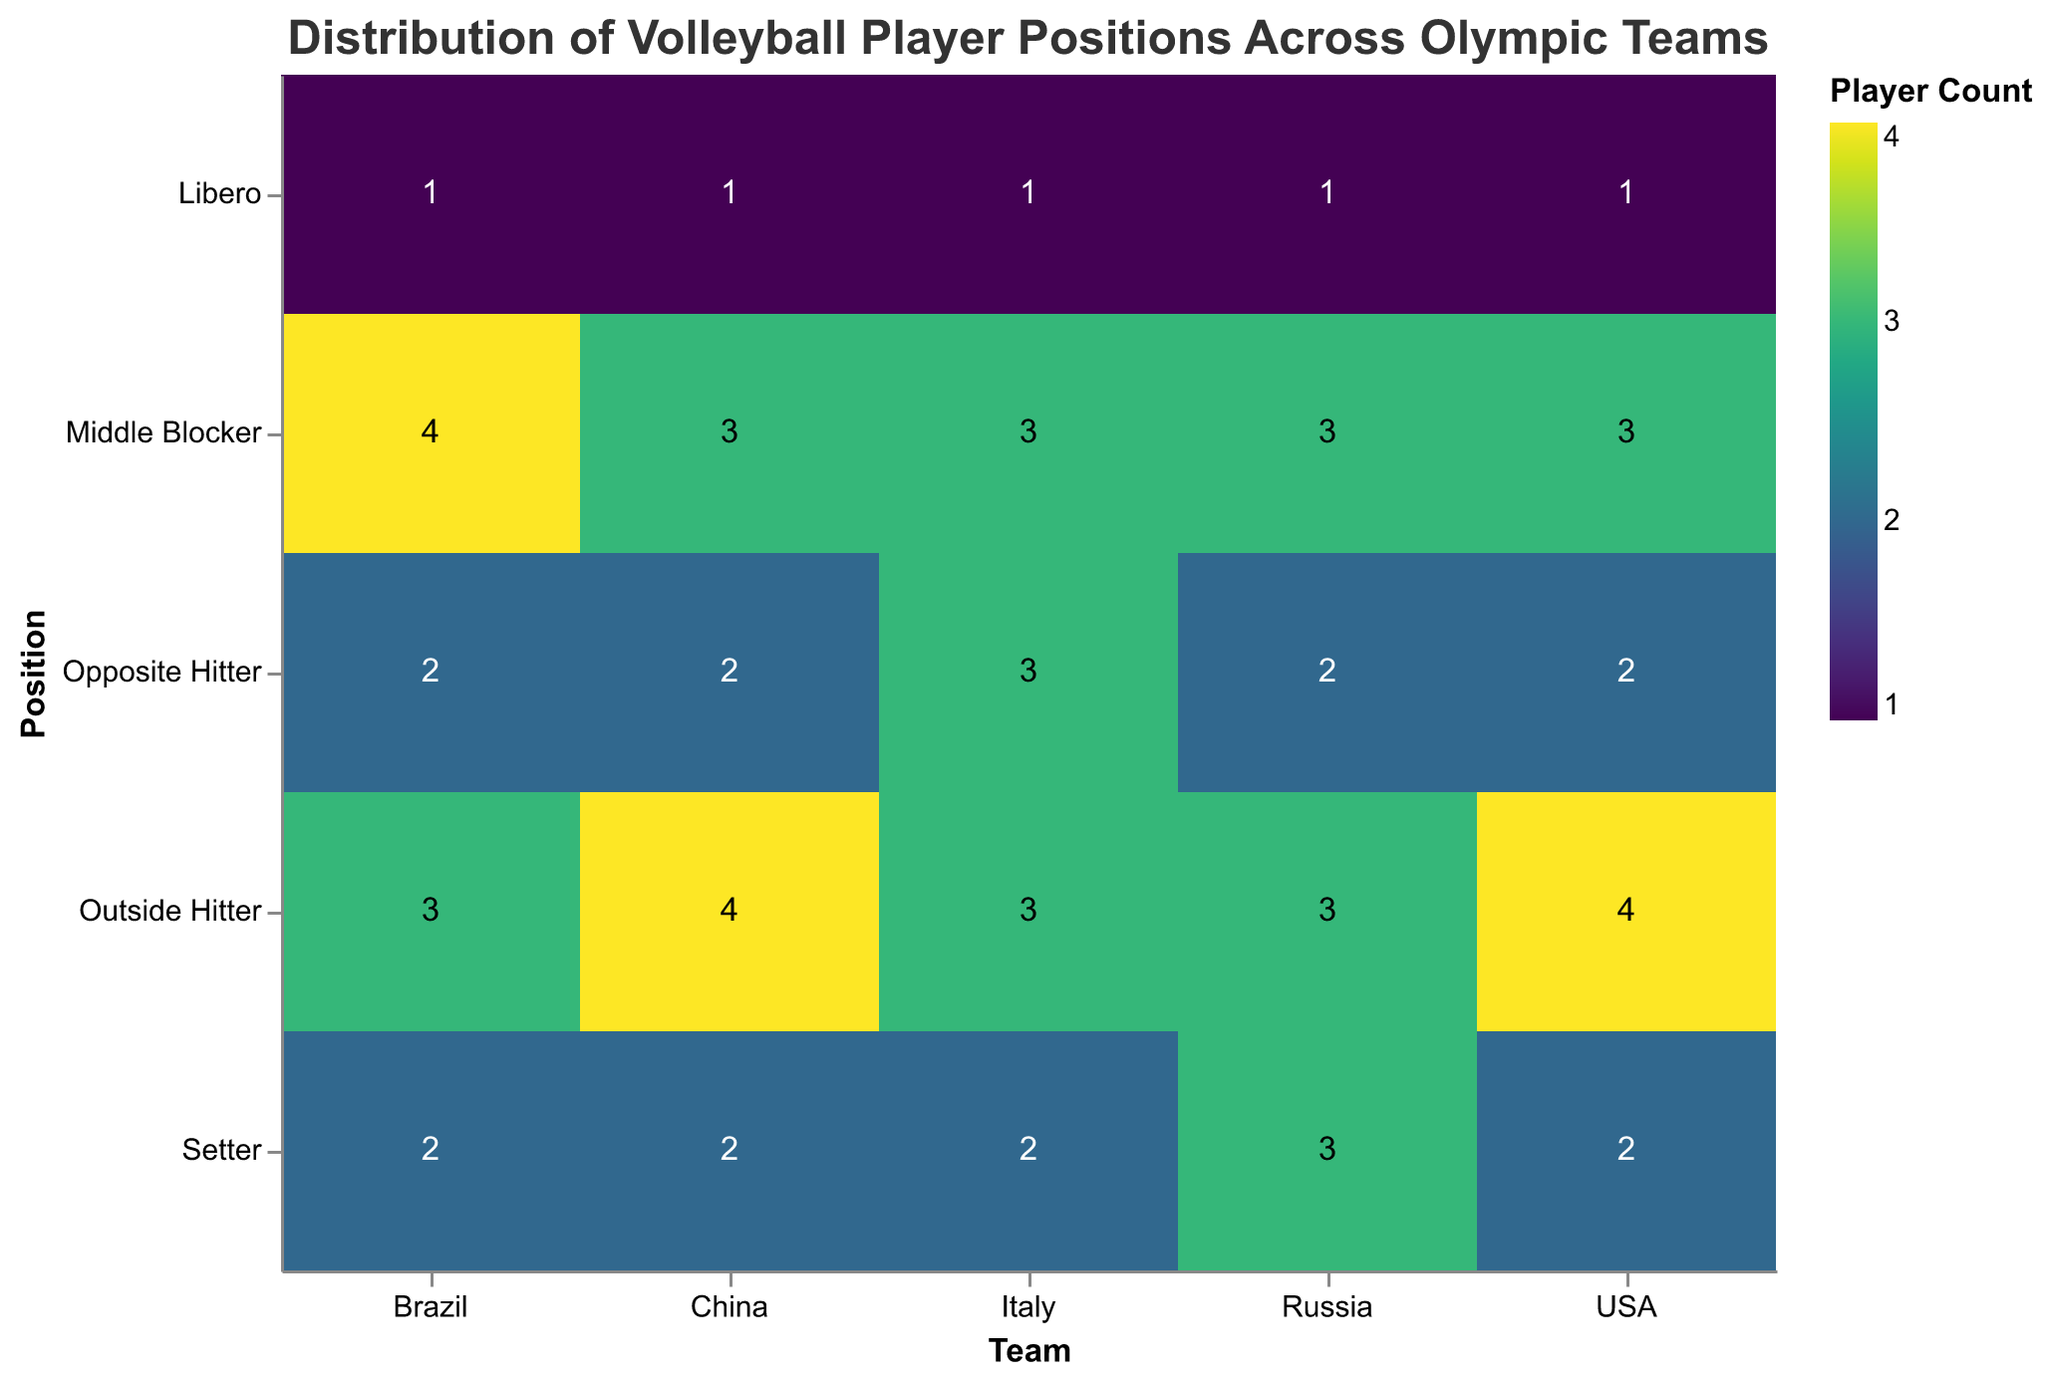What is the title of the figure? The title is displayed at the top of the figure. It reads: "Distribution of Volleyball Player Positions Across Olympic Teams".
Answer: Distribution of Volleyball Player Positions Across Olympic Teams Which team has the highest number of Outside Hitters? Looking at the y-axis representing positions and the x-axis representing teams, China and the USA both have 4 players in the Outside Hitter position, the highest count for this position among all teams.
Answer: China and USA How many Setters does Russia have? Refer to the y-axis to find the Setter position and then look at Russia on the x-axis where the corresponding cell shows the count of 3.
Answer: 3 Compare the number of Libero players across all teams. Which team has the same number as the others? All teams have the same number of 1 player for the Libero position. By glancing diagonally along the Libero row in the chart, you can see the consistent count.
Answer: All teams (USA, Brazil, Italy, Russia, China) Which team has the most Middle Blockers? By examining the Middle Blocker row across all the teams, Brazil has 4 Middle Blockers, the highest count compared to other teams.
Answer: Brazil If you sum up the total number of players for the USA, how many would you get? Add the counts for all positions in the USA (2 Setters + 4 Outside Hitters + 3 Middle Blockers + 2 Opposite Hitters + 1 Libero): 2 + 4 + 3 + 2 + 1 = 12.
Answer: 12 Which position has the lowest player count across all teams? The Libero position has the lowest count across all teams with each team having only 1 player for this position. This can be identified by comparing the counts across all position rows.
Answer: Libero Compare the number of Opposite Hitters between Italy and China. Which team has more? By comparing the Opposite Hitter position for Italy and China on the y-axis, Italy has 3 Opposite Hitters while China has 2.
Answer: Italy What is the total number of Outside Hitters in the figure? Sum up the Outside Hitters from each team (USA 4 + Brazil 3 + Italy 3 + Russia 3 + China 4): 4 + 3 + 3 + 3 + 4 = 17.
Answer: 17 Which team(s) have an equal number of players in both the Setter and Opposite Hitter positions? Examine the counts for both Setter and Opposite Hitter positions across all teams. Brazil, USA, and China each have 2 Setters and 2 Opposite Hitters, indicating they have equal counts in these positions.
Answer: Brazil, USA, China 